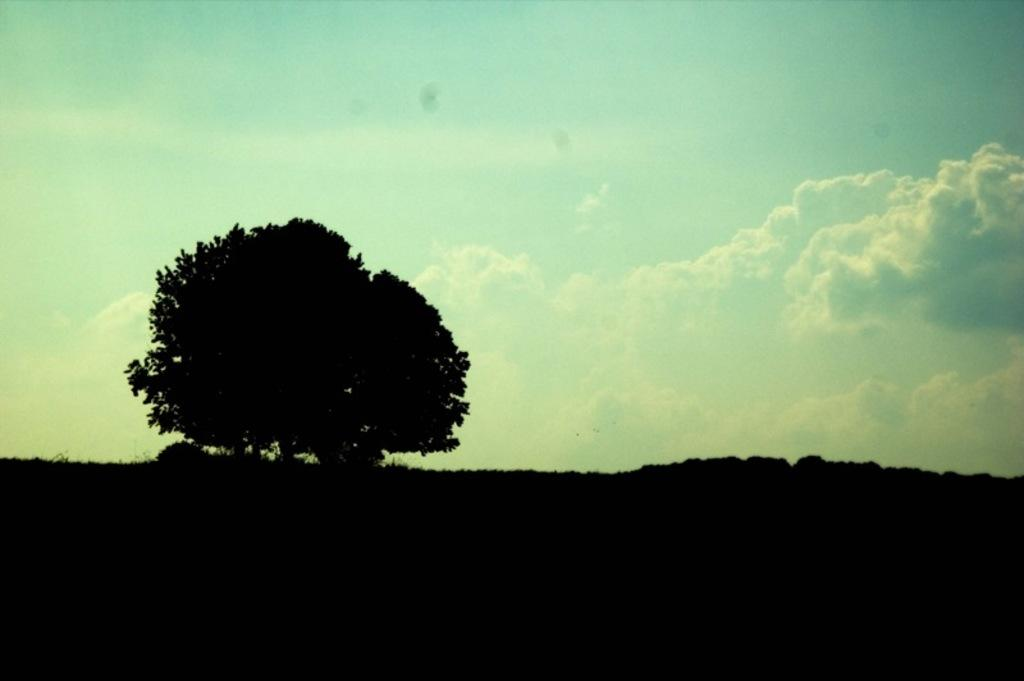What is located on the mountain in the image? There is a tree on the mountain in the image. What can be seen in the background of the image? The sky is visible in the background of the image, and clouds are present. What is the lighting condition at the bottom of the image? There is darkness at the bottom of the image. What type of toys can be seen scattered in the yard in the image? There is no yard or toys present in the image; it features a tree on a mountain with a dark background. 